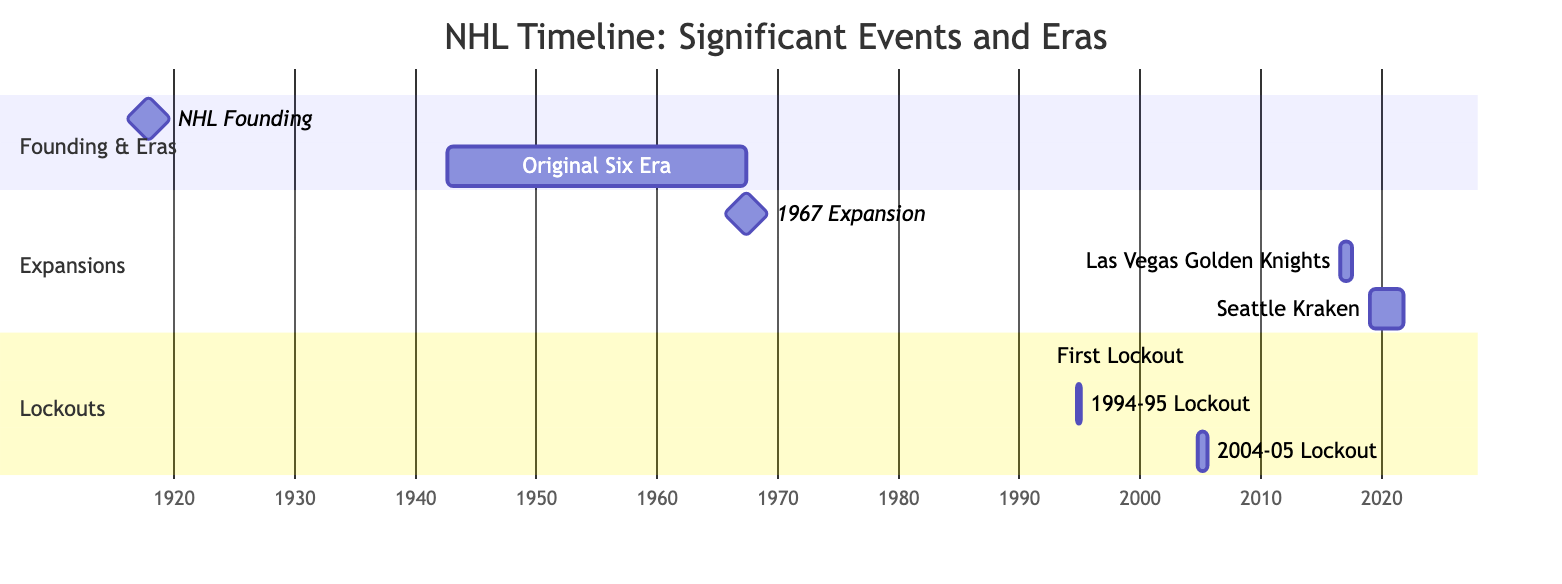What is the first event listed in the timeline? The first event in the timeline is the "NHL Founding," which signifies the establishment of the National Hockey League on November 26, 1917.
Answer: NHL Founding How many lockouts are shown in the diagram? The diagram displays three distinct lockouts, specifically "First Lockout," "1994-95 Lockout," and "2004-05 Lockout." Each lockout is indicated as a separate entry in the Lockouts section.
Answer: 3 What year did the Original Six Era start? The Original Six Era began on September 1, 1942, as indicated by the start date listed in the timeline.
Answer: 1942 Which event lasted the longest, based on the Gantt Chart? The "2004-05 Lockout" lasted the longest, from September 16, 2004, to July 22, 2005, totaling approximately 10 months. The timeline durations are oversimplified, but this is the longest visible timeline.
Answer: 2004-05 Lockout What is the duration of the Original Six Era? The Original Six Era lasted from September 1, 1942, to May 1, 1967, which totals 24 years and 8 months. This duration can be calculated by identifying the start and end dates and counting the period between them.
Answer: 24 years 8 months Which expansion team was awarded last in the timeline? The last expansion team awarded in the timeline is the "Seattle Kraken," which was announced in December 2018 and began play in October 2021. This is visually evident at the end of the Expansions section.
Answer: Seattle Kraken What significant event occurred on June 5, 1967? On June 5, 1967, the "1967 Expansion" occurred, marking a pivotal moment in NHL history as the league expanded from 6 to 12 teams. This date is highlighted as a milestone in the timeline.
Answer: 1967 Expansion How many teams were in the NHL before the 1967 Expansion? Prior to the 1967 Expansion, there were six teams in the NHL, as stated in the context of the Original Six Era.
Answer: 6 